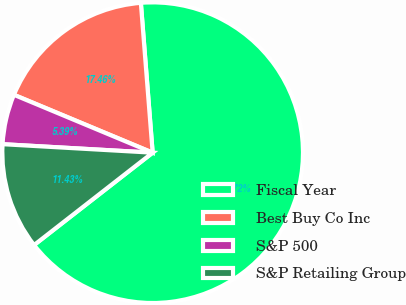<chart> <loc_0><loc_0><loc_500><loc_500><pie_chart><fcel>Fiscal Year<fcel>Best Buy Co Inc<fcel>S&P 500<fcel>S&P Retailing Group<nl><fcel>65.72%<fcel>17.46%<fcel>5.39%<fcel>11.43%<nl></chart> 